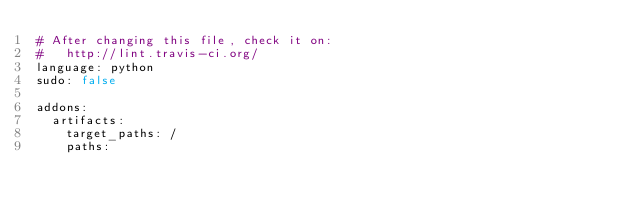<code> <loc_0><loc_0><loc_500><loc_500><_YAML_># After changing this file, check it on:
#   http://lint.travis-ci.org/
language: python
sudo: false

addons:
  artifacts:
    target_paths: /
    paths:</code> 